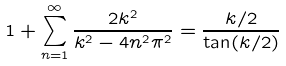<formula> <loc_0><loc_0><loc_500><loc_500>1 + \sum _ { n = 1 } ^ { \infty } \frac { 2 k ^ { 2 } } { k ^ { 2 } - 4 n ^ { 2 } \pi ^ { 2 } } = \frac { k / 2 } { \tan ( k / 2 ) }</formula> 